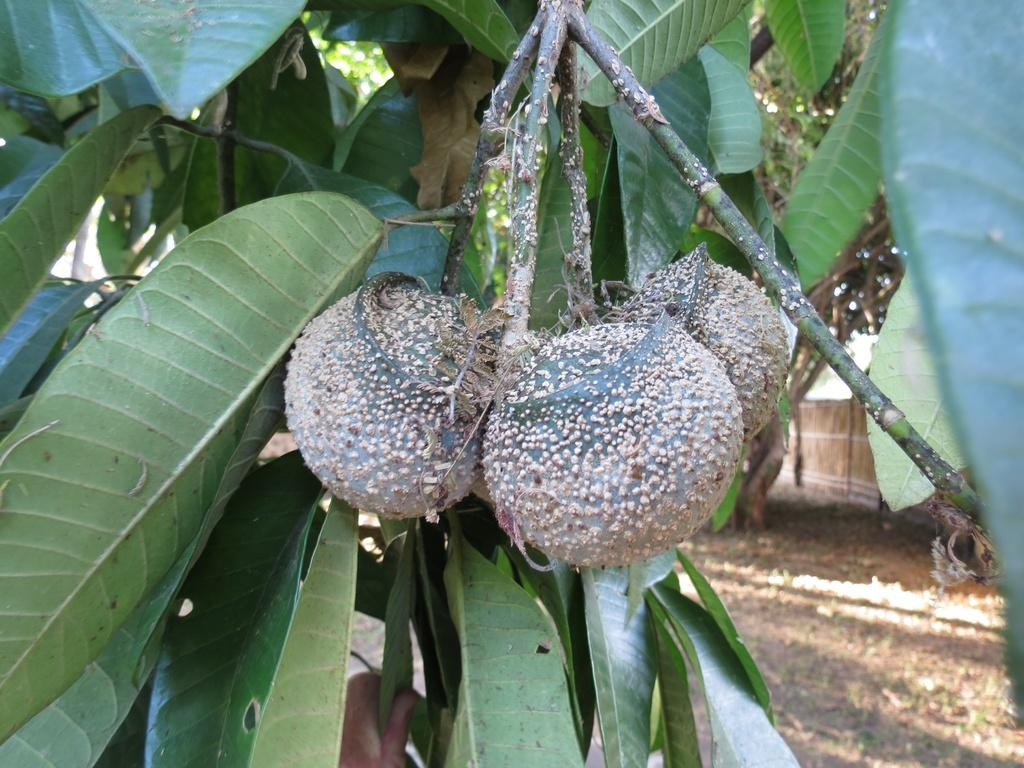What type of vegetation can be seen in the image? There is a tree visible in the image. What is on the tree in the image? There are fruits on the tree in the image. What is present at the bottom of the image? There is mud at the bottom of the image. What type of pleasure can be seen in the image? There is no indication of pleasure in the image; it features a tree with fruits and mud at the bottom. How does the image demand the user's attention? The image does not demand the user's attention in any specific way; it simply presents a tree with fruits and mud at the bottom. 